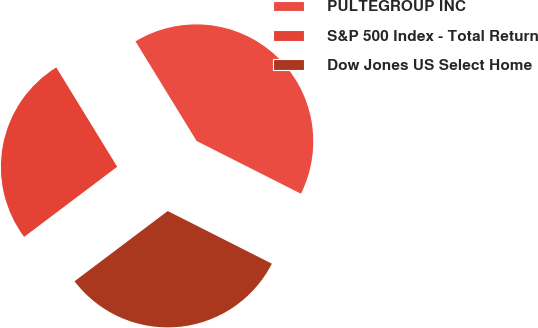Convert chart. <chart><loc_0><loc_0><loc_500><loc_500><pie_chart><fcel>PULTEGROUP INC<fcel>S&P 500 Index - Total Return<fcel>Dow Jones US Select Home<nl><fcel>41.21%<fcel>26.52%<fcel>32.27%<nl></chart> 